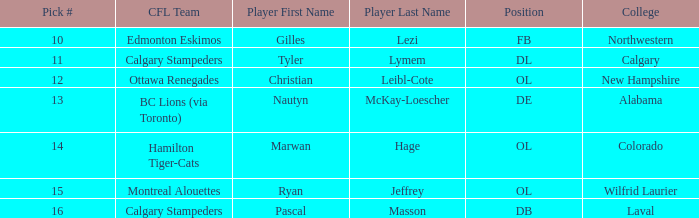Which player from the 2004 CFL draft attended Wilfrid Laurier? Ryan Jeffrey. 